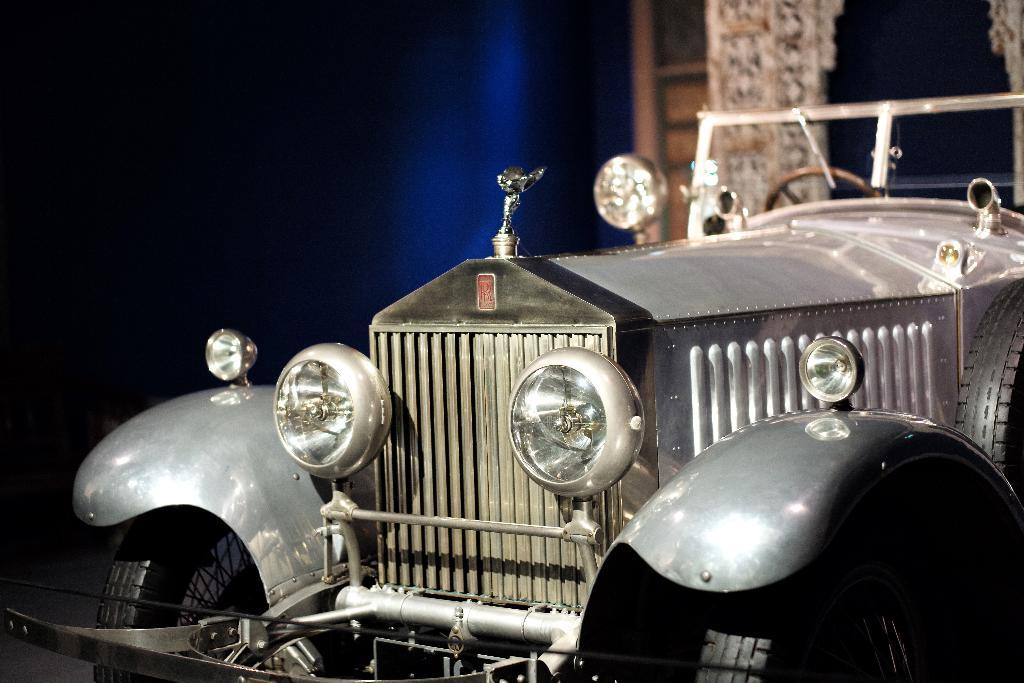What is the main subject in the center of the image? There is a vehicle in the center of the image. What can be seen at the top of the image? There is a wall visible at the top of the image, and wood is present there as well. What part of the image shows the floor? The floor is visible in the bottom left corner of the image. What word is being spoken by the vehicle in the image? There is no indication that the vehicle is speaking or that any words are present in the image. 